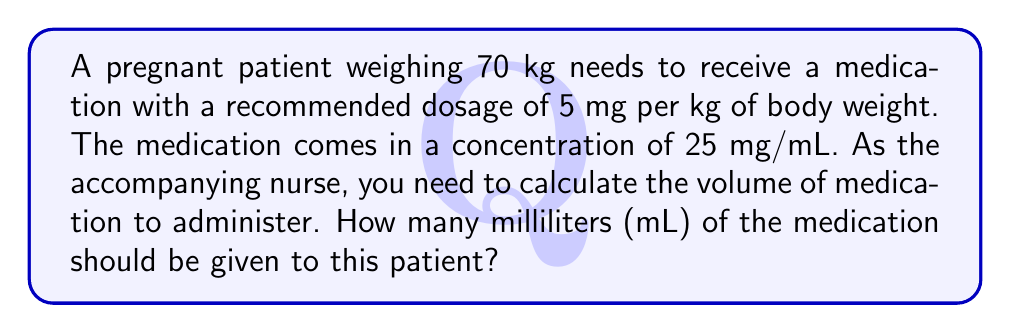Can you solve this math problem? Let's approach this step-by-step:

1) First, calculate the total dosage needed for the patient:
   $$ \text{Total dosage} = \text{Patient weight} \times \text{Dosage per kg} $$
   $$ \text{Total dosage} = 70 \text{ kg} \times 5 \text{ mg/kg} = 350 \text{ mg} $$

2) Now, we know the concentration of the medication is 25 mg/mL. We need to find out how many mL contain 350 mg.
   We can set up the following proportion:
   $$ \frac{25 \text{ mg}}{1 \text{ mL}} = \frac{350 \text{ mg}}{x \text{ mL}} $$

3) Cross multiply:
   $$ 25x = 350 $$

4) Solve for x:
   $$ x = \frac{350}{25} = 14 $$

Therefore, 14 mL of the medication should be administered to the patient.
Answer: 14 mL 